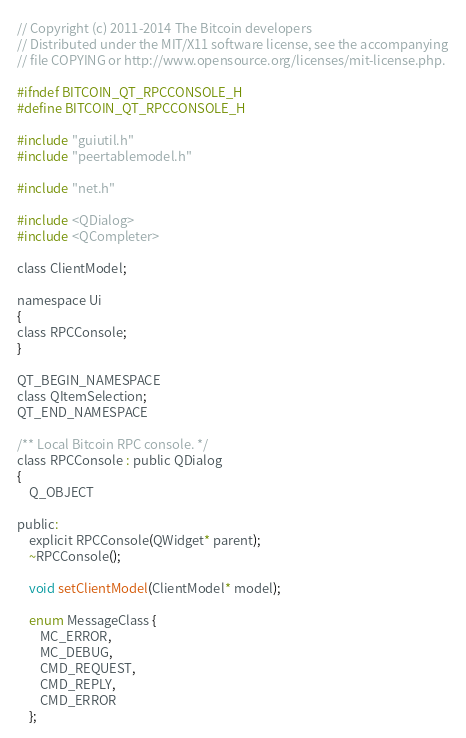Convert code to text. <code><loc_0><loc_0><loc_500><loc_500><_C_>// Copyright (c) 2011-2014 The Bitcoin developers
// Distributed under the MIT/X11 software license, see the accompanying
// file COPYING or http://www.opensource.org/licenses/mit-license.php.

#ifndef BITCOIN_QT_RPCCONSOLE_H
#define BITCOIN_QT_RPCCONSOLE_H

#include "guiutil.h"
#include "peertablemodel.h"

#include "net.h"

#include <QDialog>
#include <QCompleter>

class ClientModel;

namespace Ui
{
class RPCConsole;
}

QT_BEGIN_NAMESPACE
class QItemSelection;
QT_END_NAMESPACE

/** Local Bitcoin RPC console. */
class RPCConsole : public QDialog
{
    Q_OBJECT

public:
    explicit RPCConsole(QWidget* parent);
    ~RPCConsole();

    void setClientModel(ClientModel* model);

    enum MessageClass {
        MC_ERROR,
        MC_DEBUG,
        CMD_REQUEST,
        CMD_REPLY,
        CMD_ERROR
    };
</code> 